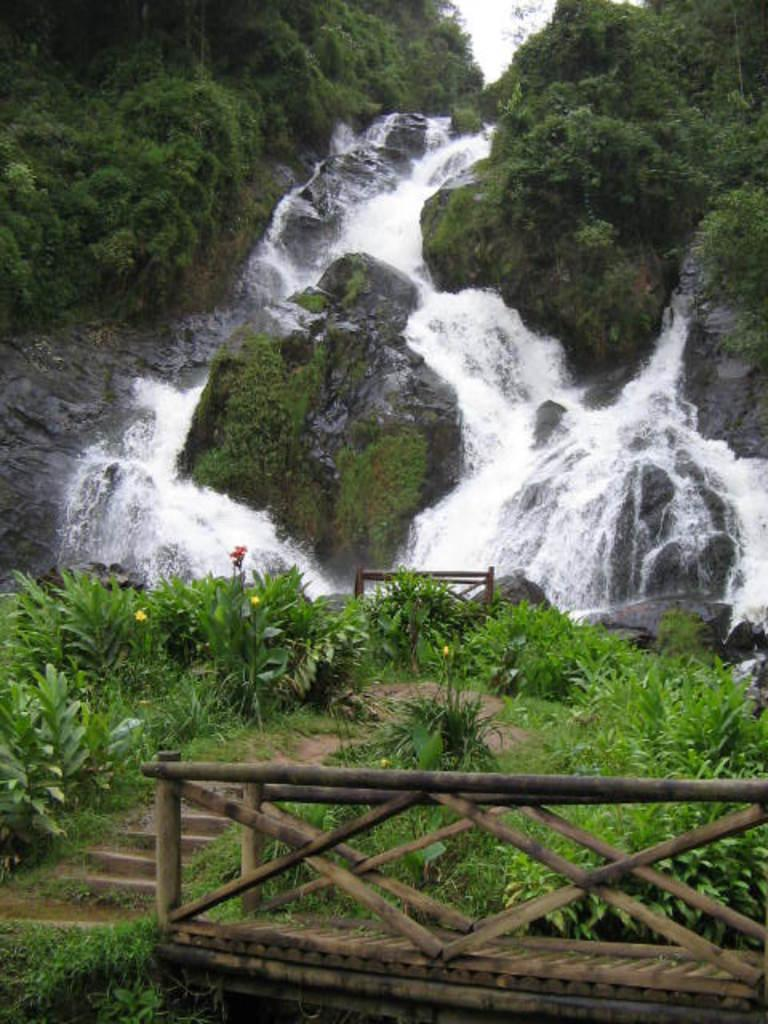What type of barrier can be seen in the image? There is a wooden fence in the image. What architectural feature is present in the image? There are steps in the image. What type of natural elements are visible in the image? There are plants and a waterfall in the image. What type of terrain is present in the image? Rocks are present in the image. What can be seen in the background of the image? Trees are visible in the background of the image. What type of pencil is used to draw the waterfall in the image? There is no pencil present in the image, as it is a photograph of a real waterfall. How do the plants join together to form the wooden fence in the image? The wooden fence is a separate structure from the plants; they do not join together to form it. 